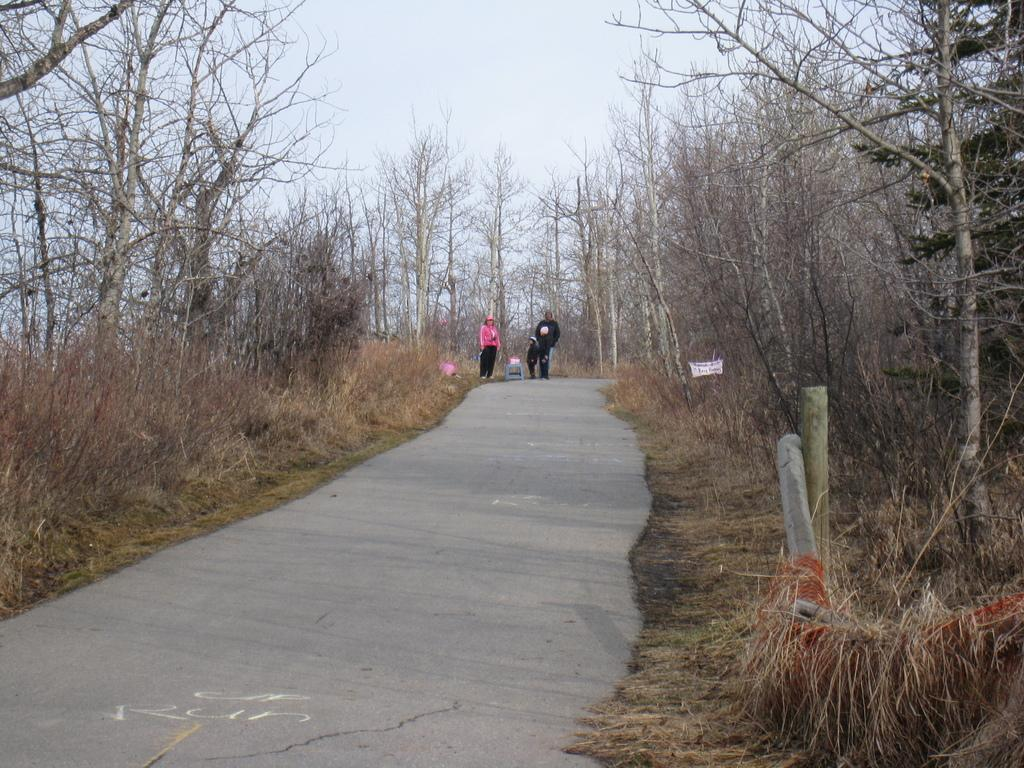What type of vegetation is present in the image? There are dry trees in the image. What else can be seen in the image besides the trees? There is a road and the sky visible in the image. Are there any people in the image? Yes, there are people in the image. What type of planes can be seen flying in the image? There are no planes visible in the image; it only features dry trees, a road, the sky, and people. Who is the writer in the image? There is no writer present in the image. 